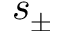<formula> <loc_0><loc_0><loc_500><loc_500>s _ { \pm }</formula> 